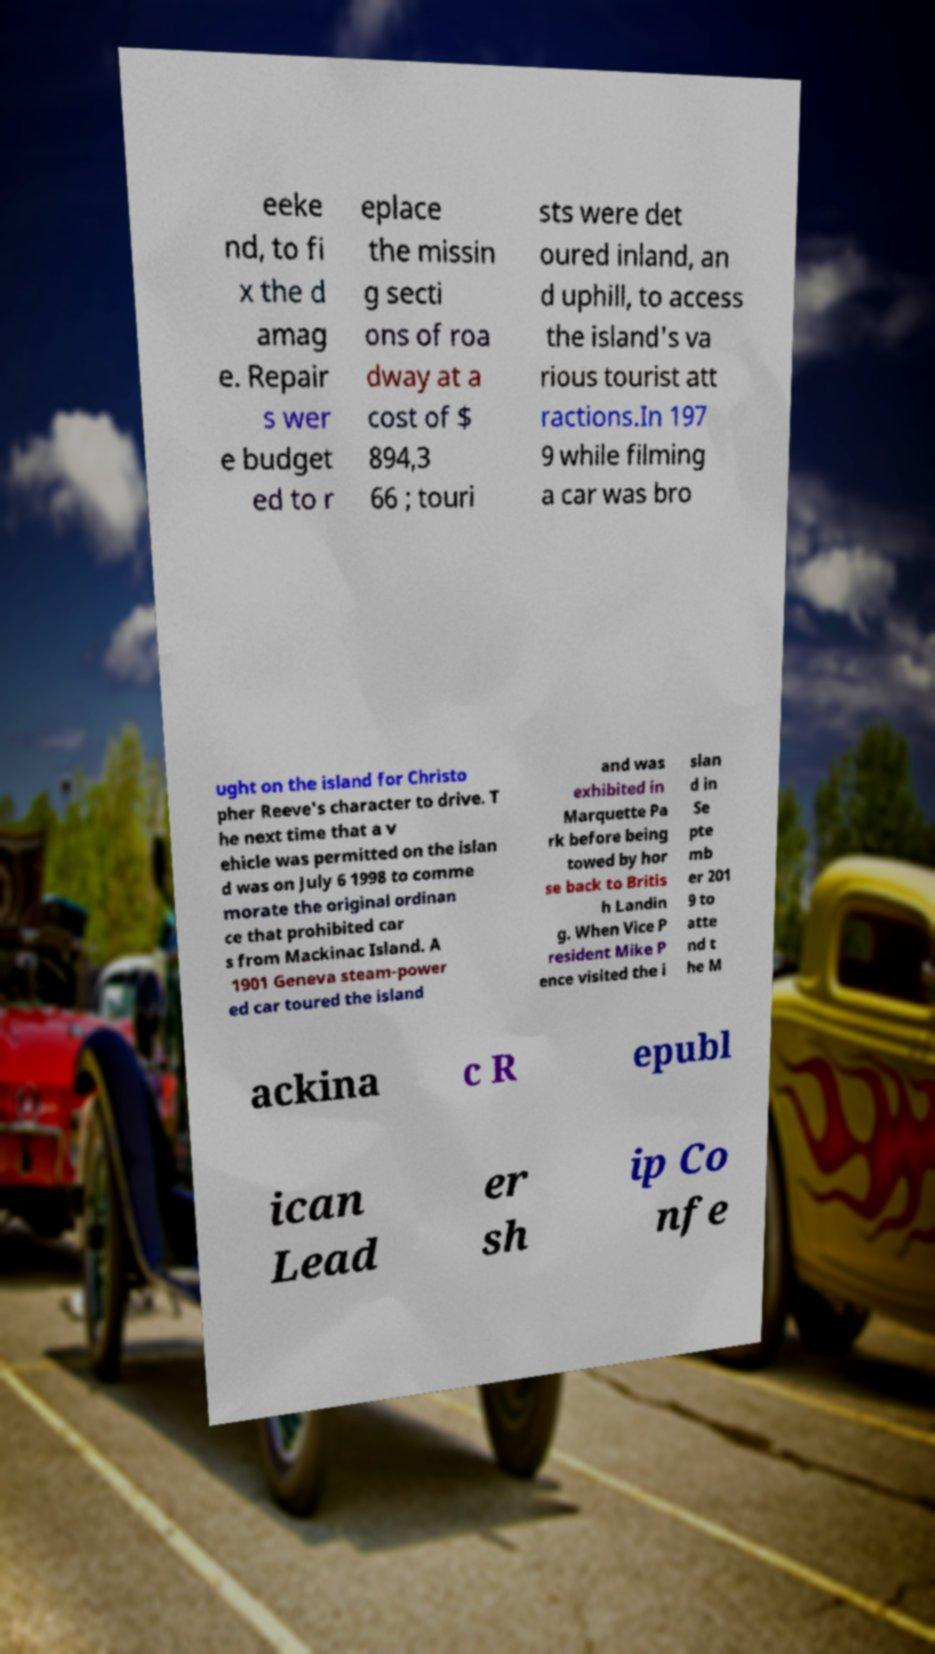There's text embedded in this image that I need extracted. Can you transcribe it verbatim? eeke nd, to fi x the d amag e. Repair s wer e budget ed to r eplace the missin g secti ons of roa dway at a cost of $ 894,3 66 ; touri sts were det oured inland, an d uphill, to access the island's va rious tourist att ractions.In 197 9 while filming a car was bro ught on the island for Christo pher Reeve's character to drive. T he next time that a v ehicle was permitted on the islan d was on July 6 1998 to comme morate the original ordinan ce that prohibited car s from Mackinac Island. A 1901 Geneva steam-power ed car toured the island and was exhibited in Marquette Pa rk before being towed by hor se back to Britis h Landin g. When Vice P resident Mike P ence visited the i slan d in Se pte mb er 201 9 to atte nd t he M ackina c R epubl ican Lead er sh ip Co nfe 